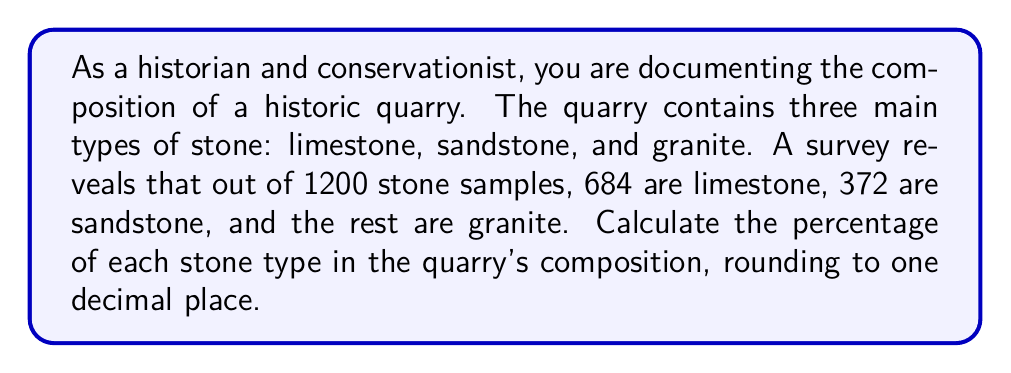Can you answer this question? To solve this problem, we need to follow these steps:

1. Calculate the number of granite samples:
   Total samples = 1200
   Limestone samples = 684
   Sandstone samples = 372
   Granite samples = 1200 - 684 - 372 = 144

2. Calculate the percentage of each stone type:
   Percentage = (Number of samples of a stone type / Total number of samples) × 100

   For limestone:
   $$ \text{Limestone percentage} = \frac{684}{1200} \times 100 = 57\% $$

   For sandstone:
   $$ \text{Sandstone percentage} = \frac{372}{1200} \times 100 = 31\% $$

   For granite:
   $$ \text{Granite percentage} = \frac{144}{1200} \times 100 = 12\% $$

3. Round each percentage to one decimal place:
   Limestone: 57.0%
   Sandstone: 31.0%
   Granite: 12.0%

Note that the sum of these percentages is 100%, confirming our calculations.
Answer: Limestone: 57.0%
Sandstone: 31.0%
Granite: 12.0% 